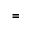<formula> <loc_0><loc_0><loc_500><loc_500>=</formula> 